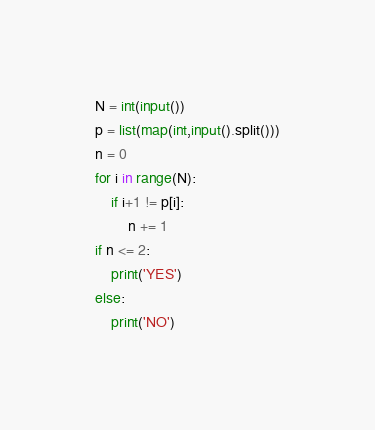Convert code to text. <code><loc_0><loc_0><loc_500><loc_500><_Python_>N = int(input())
p = list(map(int,input().split()))
n = 0
for i in range(N):
    if i+1 != p[i]:
        n += 1
if n <= 2:
    print('YES')
else:
    print('NO')</code> 